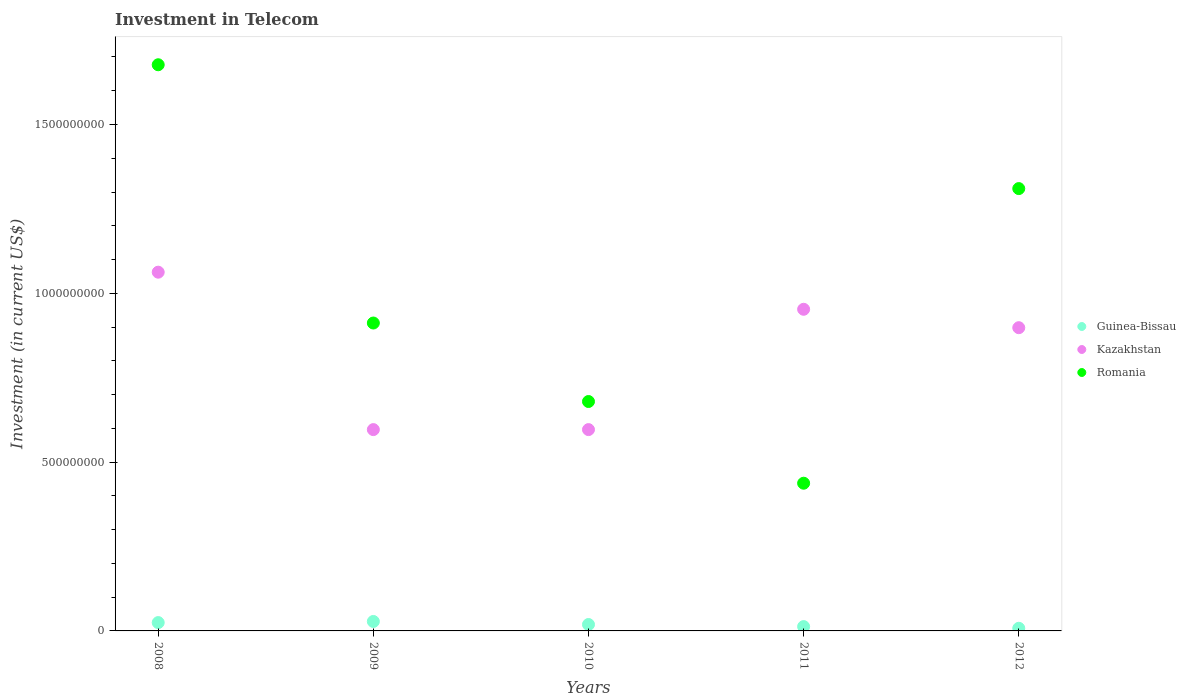How many different coloured dotlines are there?
Ensure brevity in your answer.  3. Is the number of dotlines equal to the number of legend labels?
Provide a short and direct response. Yes. What is the amount invested in telecom in Kazakhstan in 2012?
Ensure brevity in your answer.  8.98e+08. Across all years, what is the maximum amount invested in telecom in Romania?
Provide a succinct answer. 1.68e+09. Across all years, what is the minimum amount invested in telecom in Guinea-Bissau?
Provide a short and direct response. 7.80e+06. In which year was the amount invested in telecom in Guinea-Bissau maximum?
Keep it short and to the point. 2009. What is the total amount invested in telecom in Guinea-Bissau in the graph?
Provide a short and direct response. 9.23e+07. What is the difference between the amount invested in telecom in Kazakhstan in 2010 and the amount invested in telecom in Romania in 2008?
Your response must be concise. -1.08e+09. What is the average amount invested in telecom in Guinea-Bissau per year?
Provide a short and direct response. 1.85e+07. In the year 2011, what is the difference between the amount invested in telecom in Guinea-Bissau and amount invested in telecom in Romania?
Your answer should be compact. -4.25e+08. In how many years, is the amount invested in telecom in Kazakhstan greater than 600000000 US$?
Give a very brief answer. 3. What is the ratio of the amount invested in telecom in Kazakhstan in 2009 to that in 2012?
Provide a succinct answer. 0.66. Is the amount invested in telecom in Guinea-Bissau in 2008 less than that in 2011?
Provide a succinct answer. No. Is the difference between the amount invested in telecom in Guinea-Bissau in 2009 and 2011 greater than the difference between the amount invested in telecom in Romania in 2009 and 2011?
Provide a short and direct response. No. What is the difference between the highest and the second highest amount invested in telecom in Kazakhstan?
Offer a terse response. 1.10e+08. What is the difference between the highest and the lowest amount invested in telecom in Romania?
Your answer should be compact. 1.24e+09. In how many years, is the amount invested in telecom in Guinea-Bissau greater than the average amount invested in telecom in Guinea-Bissau taken over all years?
Give a very brief answer. 3. Is it the case that in every year, the sum of the amount invested in telecom in Guinea-Bissau and amount invested in telecom in Kazakhstan  is greater than the amount invested in telecom in Romania?
Keep it short and to the point. No. How many dotlines are there?
Keep it short and to the point. 3. How many years are there in the graph?
Provide a short and direct response. 5. How many legend labels are there?
Offer a very short reply. 3. How are the legend labels stacked?
Your answer should be compact. Vertical. What is the title of the graph?
Offer a terse response. Investment in Telecom. What is the label or title of the X-axis?
Make the answer very short. Years. What is the label or title of the Y-axis?
Provide a short and direct response. Investment (in current US$). What is the Investment (in current US$) of Guinea-Bissau in 2008?
Your answer should be compact. 2.47e+07. What is the Investment (in current US$) of Kazakhstan in 2008?
Your answer should be compact. 1.06e+09. What is the Investment (in current US$) of Romania in 2008?
Provide a succinct answer. 1.68e+09. What is the Investment (in current US$) of Guinea-Bissau in 2009?
Your answer should be compact. 2.80e+07. What is the Investment (in current US$) in Kazakhstan in 2009?
Provide a succinct answer. 5.96e+08. What is the Investment (in current US$) in Romania in 2009?
Your response must be concise. 9.12e+08. What is the Investment (in current US$) in Guinea-Bissau in 2010?
Give a very brief answer. 1.90e+07. What is the Investment (in current US$) in Kazakhstan in 2010?
Provide a succinct answer. 5.96e+08. What is the Investment (in current US$) of Romania in 2010?
Keep it short and to the point. 6.80e+08. What is the Investment (in current US$) in Guinea-Bissau in 2011?
Ensure brevity in your answer.  1.28e+07. What is the Investment (in current US$) in Kazakhstan in 2011?
Offer a terse response. 9.53e+08. What is the Investment (in current US$) of Romania in 2011?
Make the answer very short. 4.38e+08. What is the Investment (in current US$) of Guinea-Bissau in 2012?
Offer a terse response. 7.80e+06. What is the Investment (in current US$) of Kazakhstan in 2012?
Your answer should be compact. 8.98e+08. What is the Investment (in current US$) of Romania in 2012?
Your answer should be compact. 1.31e+09. Across all years, what is the maximum Investment (in current US$) of Guinea-Bissau?
Your response must be concise. 2.80e+07. Across all years, what is the maximum Investment (in current US$) of Kazakhstan?
Provide a succinct answer. 1.06e+09. Across all years, what is the maximum Investment (in current US$) in Romania?
Ensure brevity in your answer.  1.68e+09. Across all years, what is the minimum Investment (in current US$) in Guinea-Bissau?
Offer a very short reply. 7.80e+06. Across all years, what is the minimum Investment (in current US$) of Kazakhstan?
Offer a terse response. 5.96e+08. Across all years, what is the minimum Investment (in current US$) in Romania?
Your answer should be compact. 4.38e+08. What is the total Investment (in current US$) of Guinea-Bissau in the graph?
Provide a succinct answer. 9.23e+07. What is the total Investment (in current US$) of Kazakhstan in the graph?
Keep it short and to the point. 4.11e+09. What is the total Investment (in current US$) of Romania in the graph?
Keep it short and to the point. 5.02e+09. What is the difference between the Investment (in current US$) of Guinea-Bissau in 2008 and that in 2009?
Ensure brevity in your answer.  -3.30e+06. What is the difference between the Investment (in current US$) in Kazakhstan in 2008 and that in 2009?
Your response must be concise. 4.66e+08. What is the difference between the Investment (in current US$) of Romania in 2008 and that in 2009?
Make the answer very short. 7.65e+08. What is the difference between the Investment (in current US$) in Guinea-Bissau in 2008 and that in 2010?
Provide a short and direct response. 5.70e+06. What is the difference between the Investment (in current US$) of Kazakhstan in 2008 and that in 2010?
Give a very brief answer. 4.66e+08. What is the difference between the Investment (in current US$) of Romania in 2008 and that in 2010?
Your response must be concise. 9.98e+08. What is the difference between the Investment (in current US$) of Guinea-Bissau in 2008 and that in 2011?
Your response must be concise. 1.19e+07. What is the difference between the Investment (in current US$) in Kazakhstan in 2008 and that in 2011?
Your answer should be very brief. 1.10e+08. What is the difference between the Investment (in current US$) of Romania in 2008 and that in 2011?
Your answer should be compact. 1.24e+09. What is the difference between the Investment (in current US$) of Guinea-Bissau in 2008 and that in 2012?
Keep it short and to the point. 1.69e+07. What is the difference between the Investment (in current US$) of Kazakhstan in 2008 and that in 2012?
Provide a succinct answer. 1.64e+08. What is the difference between the Investment (in current US$) in Romania in 2008 and that in 2012?
Provide a short and direct response. 3.67e+08. What is the difference between the Investment (in current US$) in Guinea-Bissau in 2009 and that in 2010?
Your answer should be very brief. 9.00e+06. What is the difference between the Investment (in current US$) of Kazakhstan in 2009 and that in 2010?
Your response must be concise. 0. What is the difference between the Investment (in current US$) in Romania in 2009 and that in 2010?
Your answer should be compact. 2.32e+08. What is the difference between the Investment (in current US$) of Guinea-Bissau in 2009 and that in 2011?
Offer a terse response. 1.52e+07. What is the difference between the Investment (in current US$) in Kazakhstan in 2009 and that in 2011?
Your response must be concise. -3.56e+08. What is the difference between the Investment (in current US$) in Romania in 2009 and that in 2011?
Make the answer very short. 4.74e+08. What is the difference between the Investment (in current US$) in Guinea-Bissau in 2009 and that in 2012?
Provide a short and direct response. 2.02e+07. What is the difference between the Investment (in current US$) in Kazakhstan in 2009 and that in 2012?
Keep it short and to the point. -3.02e+08. What is the difference between the Investment (in current US$) in Romania in 2009 and that in 2012?
Keep it short and to the point. -3.98e+08. What is the difference between the Investment (in current US$) of Guinea-Bissau in 2010 and that in 2011?
Make the answer very short. 6.20e+06. What is the difference between the Investment (in current US$) of Kazakhstan in 2010 and that in 2011?
Make the answer very short. -3.56e+08. What is the difference between the Investment (in current US$) in Romania in 2010 and that in 2011?
Your answer should be compact. 2.42e+08. What is the difference between the Investment (in current US$) of Guinea-Bissau in 2010 and that in 2012?
Provide a succinct answer. 1.12e+07. What is the difference between the Investment (in current US$) in Kazakhstan in 2010 and that in 2012?
Your answer should be very brief. -3.02e+08. What is the difference between the Investment (in current US$) in Romania in 2010 and that in 2012?
Offer a terse response. -6.31e+08. What is the difference between the Investment (in current US$) in Guinea-Bissau in 2011 and that in 2012?
Offer a terse response. 5.00e+06. What is the difference between the Investment (in current US$) in Kazakhstan in 2011 and that in 2012?
Offer a terse response. 5.45e+07. What is the difference between the Investment (in current US$) of Romania in 2011 and that in 2012?
Keep it short and to the point. -8.73e+08. What is the difference between the Investment (in current US$) in Guinea-Bissau in 2008 and the Investment (in current US$) in Kazakhstan in 2009?
Offer a terse response. -5.72e+08. What is the difference between the Investment (in current US$) in Guinea-Bissau in 2008 and the Investment (in current US$) in Romania in 2009?
Make the answer very short. -8.87e+08. What is the difference between the Investment (in current US$) in Kazakhstan in 2008 and the Investment (in current US$) in Romania in 2009?
Offer a terse response. 1.51e+08. What is the difference between the Investment (in current US$) of Guinea-Bissau in 2008 and the Investment (in current US$) of Kazakhstan in 2010?
Provide a succinct answer. -5.72e+08. What is the difference between the Investment (in current US$) of Guinea-Bissau in 2008 and the Investment (in current US$) of Romania in 2010?
Offer a terse response. -6.55e+08. What is the difference between the Investment (in current US$) of Kazakhstan in 2008 and the Investment (in current US$) of Romania in 2010?
Offer a very short reply. 3.83e+08. What is the difference between the Investment (in current US$) of Guinea-Bissau in 2008 and the Investment (in current US$) of Kazakhstan in 2011?
Offer a terse response. -9.28e+08. What is the difference between the Investment (in current US$) of Guinea-Bissau in 2008 and the Investment (in current US$) of Romania in 2011?
Keep it short and to the point. -4.13e+08. What is the difference between the Investment (in current US$) of Kazakhstan in 2008 and the Investment (in current US$) of Romania in 2011?
Your response must be concise. 6.25e+08. What is the difference between the Investment (in current US$) of Guinea-Bissau in 2008 and the Investment (in current US$) of Kazakhstan in 2012?
Your response must be concise. -8.73e+08. What is the difference between the Investment (in current US$) in Guinea-Bissau in 2008 and the Investment (in current US$) in Romania in 2012?
Provide a succinct answer. -1.29e+09. What is the difference between the Investment (in current US$) in Kazakhstan in 2008 and the Investment (in current US$) in Romania in 2012?
Give a very brief answer. -2.48e+08. What is the difference between the Investment (in current US$) of Guinea-Bissau in 2009 and the Investment (in current US$) of Kazakhstan in 2010?
Make the answer very short. -5.68e+08. What is the difference between the Investment (in current US$) of Guinea-Bissau in 2009 and the Investment (in current US$) of Romania in 2010?
Your answer should be very brief. -6.52e+08. What is the difference between the Investment (in current US$) in Kazakhstan in 2009 and the Investment (in current US$) in Romania in 2010?
Provide a succinct answer. -8.32e+07. What is the difference between the Investment (in current US$) of Guinea-Bissau in 2009 and the Investment (in current US$) of Kazakhstan in 2011?
Your answer should be compact. -9.25e+08. What is the difference between the Investment (in current US$) of Guinea-Bissau in 2009 and the Investment (in current US$) of Romania in 2011?
Provide a short and direct response. -4.10e+08. What is the difference between the Investment (in current US$) of Kazakhstan in 2009 and the Investment (in current US$) of Romania in 2011?
Make the answer very short. 1.59e+08. What is the difference between the Investment (in current US$) of Guinea-Bissau in 2009 and the Investment (in current US$) of Kazakhstan in 2012?
Offer a very short reply. -8.70e+08. What is the difference between the Investment (in current US$) of Guinea-Bissau in 2009 and the Investment (in current US$) of Romania in 2012?
Your response must be concise. -1.28e+09. What is the difference between the Investment (in current US$) of Kazakhstan in 2009 and the Investment (in current US$) of Romania in 2012?
Offer a very short reply. -7.14e+08. What is the difference between the Investment (in current US$) of Guinea-Bissau in 2010 and the Investment (in current US$) of Kazakhstan in 2011?
Provide a succinct answer. -9.34e+08. What is the difference between the Investment (in current US$) in Guinea-Bissau in 2010 and the Investment (in current US$) in Romania in 2011?
Your response must be concise. -4.18e+08. What is the difference between the Investment (in current US$) in Kazakhstan in 2010 and the Investment (in current US$) in Romania in 2011?
Your answer should be very brief. 1.59e+08. What is the difference between the Investment (in current US$) in Guinea-Bissau in 2010 and the Investment (in current US$) in Kazakhstan in 2012?
Your answer should be very brief. -8.79e+08. What is the difference between the Investment (in current US$) of Guinea-Bissau in 2010 and the Investment (in current US$) of Romania in 2012?
Keep it short and to the point. -1.29e+09. What is the difference between the Investment (in current US$) of Kazakhstan in 2010 and the Investment (in current US$) of Romania in 2012?
Your response must be concise. -7.14e+08. What is the difference between the Investment (in current US$) of Guinea-Bissau in 2011 and the Investment (in current US$) of Kazakhstan in 2012?
Make the answer very short. -8.85e+08. What is the difference between the Investment (in current US$) in Guinea-Bissau in 2011 and the Investment (in current US$) in Romania in 2012?
Keep it short and to the point. -1.30e+09. What is the difference between the Investment (in current US$) of Kazakhstan in 2011 and the Investment (in current US$) of Romania in 2012?
Your response must be concise. -3.58e+08. What is the average Investment (in current US$) of Guinea-Bissau per year?
Offer a terse response. 1.85e+07. What is the average Investment (in current US$) of Kazakhstan per year?
Ensure brevity in your answer.  8.21e+08. What is the average Investment (in current US$) in Romania per year?
Your answer should be very brief. 1.00e+09. In the year 2008, what is the difference between the Investment (in current US$) in Guinea-Bissau and Investment (in current US$) in Kazakhstan?
Offer a very short reply. -1.04e+09. In the year 2008, what is the difference between the Investment (in current US$) of Guinea-Bissau and Investment (in current US$) of Romania?
Ensure brevity in your answer.  -1.65e+09. In the year 2008, what is the difference between the Investment (in current US$) of Kazakhstan and Investment (in current US$) of Romania?
Give a very brief answer. -6.14e+08. In the year 2009, what is the difference between the Investment (in current US$) of Guinea-Bissau and Investment (in current US$) of Kazakhstan?
Offer a terse response. -5.68e+08. In the year 2009, what is the difference between the Investment (in current US$) in Guinea-Bissau and Investment (in current US$) in Romania?
Keep it short and to the point. -8.84e+08. In the year 2009, what is the difference between the Investment (in current US$) in Kazakhstan and Investment (in current US$) in Romania?
Make the answer very short. -3.16e+08. In the year 2010, what is the difference between the Investment (in current US$) of Guinea-Bissau and Investment (in current US$) of Kazakhstan?
Provide a succinct answer. -5.77e+08. In the year 2010, what is the difference between the Investment (in current US$) in Guinea-Bissau and Investment (in current US$) in Romania?
Provide a succinct answer. -6.60e+08. In the year 2010, what is the difference between the Investment (in current US$) of Kazakhstan and Investment (in current US$) of Romania?
Provide a succinct answer. -8.32e+07. In the year 2011, what is the difference between the Investment (in current US$) in Guinea-Bissau and Investment (in current US$) in Kazakhstan?
Ensure brevity in your answer.  -9.40e+08. In the year 2011, what is the difference between the Investment (in current US$) in Guinea-Bissau and Investment (in current US$) in Romania?
Provide a short and direct response. -4.25e+08. In the year 2011, what is the difference between the Investment (in current US$) in Kazakhstan and Investment (in current US$) in Romania?
Provide a short and direct response. 5.15e+08. In the year 2012, what is the difference between the Investment (in current US$) of Guinea-Bissau and Investment (in current US$) of Kazakhstan?
Provide a succinct answer. -8.90e+08. In the year 2012, what is the difference between the Investment (in current US$) of Guinea-Bissau and Investment (in current US$) of Romania?
Provide a succinct answer. -1.30e+09. In the year 2012, what is the difference between the Investment (in current US$) of Kazakhstan and Investment (in current US$) of Romania?
Your answer should be compact. -4.12e+08. What is the ratio of the Investment (in current US$) of Guinea-Bissau in 2008 to that in 2009?
Offer a very short reply. 0.88. What is the ratio of the Investment (in current US$) of Kazakhstan in 2008 to that in 2009?
Give a very brief answer. 1.78. What is the ratio of the Investment (in current US$) in Romania in 2008 to that in 2009?
Provide a succinct answer. 1.84. What is the ratio of the Investment (in current US$) in Guinea-Bissau in 2008 to that in 2010?
Your answer should be compact. 1.3. What is the ratio of the Investment (in current US$) in Kazakhstan in 2008 to that in 2010?
Provide a succinct answer. 1.78. What is the ratio of the Investment (in current US$) of Romania in 2008 to that in 2010?
Your answer should be compact. 2.47. What is the ratio of the Investment (in current US$) of Guinea-Bissau in 2008 to that in 2011?
Offer a very short reply. 1.93. What is the ratio of the Investment (in current US$) of Kazakhstan in 2008 to that in 2011?
Provide a short and direct response. 1.12. What is the ratio of the Investment (in current US$) of Romania in 2008 to that in 2011?
Keep it short and to the point. 3.83. What is the ratio of the Investment (in current US$) of Guinea-Bissau in 2008 to that in 2012?
Your answer should be compact. 3.17. What is the ratio of the Investment (in current US$) in Kazakhstan in 2008 to that in 2012?
Ensure brevity in your answer.  1.18. What is the ratio of the Investment (in current US$) of Romania in 2008 to that in 2012?
Your response must be concise. 1.28. What is the ratio of the Investment (in current US$) in Guinea-Bissau in 2009 to that in 2010?
Your answer should be very brief. 1.47. What is the ratio of the Investment (in current US$) of Kazakhstan in 2009 to that in 2010?
Give a very brief answer. 1. What is the ratio of the Investment (in current US$) in Romania in 2009 to that in 2010?
Offer a terse response. 1.34. What is the ratio of the Investment (in current US$) in Guinea-Bissau in 2009 to that in 2011?
Your answer should be very brief. 2.19. What is the ratio of the Investment (in current US$) of Kazakhstan in 2009 to that in 2011?
Offer a terse response. 0.63. What is the ratio of the Investment (in current US$) in Romania in 2009 to that in 2011?
Keep it short and to the point. 2.08. What is the ratio of the Investment (in current US$) of Guinea-Bissau in 2009 to that in 2012?
Give a very brief answer. 3.59. What is the ratio of the Investment (in current US$) in Kazakhstan in 2009 to that in 2012?
Offer a terse response. 0.66. What is the ratio of the Investment (in current US$) in Romania in 2009 to that in 2012?
Your response must be concise. 0.7. What is the ratio of the Investment (in current US$) in Guinea-Bissau in 2010 to that in 2011?
Offer a very short reply. 1.48. What is the ratio of the Investment (in current US$) of Kazakhstan in 2010 to that in 2011?
Make the answer very short. 0.63. What is the ratio of the Investment (in current US$) of Romania in 2010 to that in 2011?
Your answer should be very brief. 1.55. What is the ratio of the Investment (in current US$) in Guinea-Bissau in 2010 to that in 2012?
Make the answer very short. 2.44. What is the ratio of the Investment (in current US$) of Kazakhstan in 2010 to that in 2012?
Offer a very short reply. 0.66. What is the ratio of the Investment (in current US$) of Romania in 2010 to that in 2012?
Offer a terse response. 0.52. What is the ratio of the Investment (in current US$) in Guinea-Bissau in 2011 to that in 2012?
Ensure brevity in your answer.  1.64. What is the ratio of the Investment (in current US$) in Kazakhstan in 2011 to that in 2012?
Give a very brief answer. 1.06. What is the ratio of the Investment (in current US$) of Romania in 2011 to that in 2012?
Make the answer very short. 0.33. What is the difference between the highest and the second highest Investment (in current US$) in Guinea-Bissau?
Offer a terse response. 3.30e+06. What is the difference between the highest and the second highest Investment (in current US$) in Kazakhstan?
Give a very brief answer. 1.10e+08. What is the difference between the highest and the second highest Investment (in current US$) of Romania?
Your answer should be compact. 3.67e+08. What is the difference between the highest and the lowest Investment (in current US$) in Guinea-Bissau?
Your response must be concise. 2.02e+07. What is the difference between the highest and the lowest Investment (in current US$) of Kazakhstan?
Provide a short and direct response. 4.66e+08. What is the difference between the highest and the lowest Investment (in current US$) of Romania?
Your answer should be very brief. 1.24e+09. 